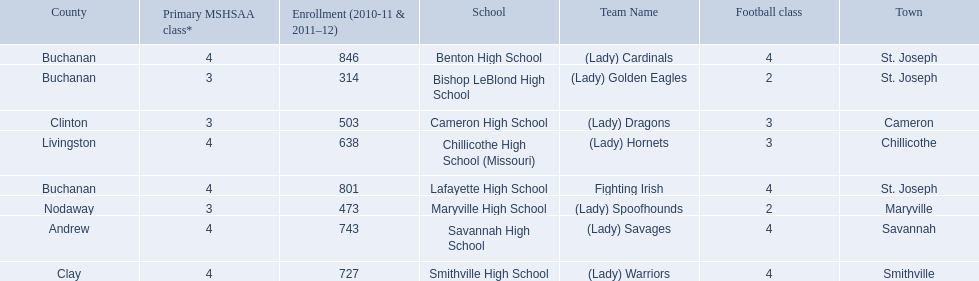What is the lowest number of students enrolled at a school as listed here? 314. What school has 314 students enrolled? Bishop LeBlond High School. 